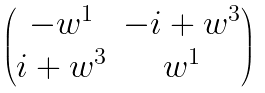Convert formula to latex. <formula><loc_0><loc_0><loc_500><loc_500>\begin{pmatrix} - w ^ { 1 } & - i + w ^ { 3 } \\ i + w ^ { 3 } & w ^ { 1 } \end{pmatrix}</formula> 